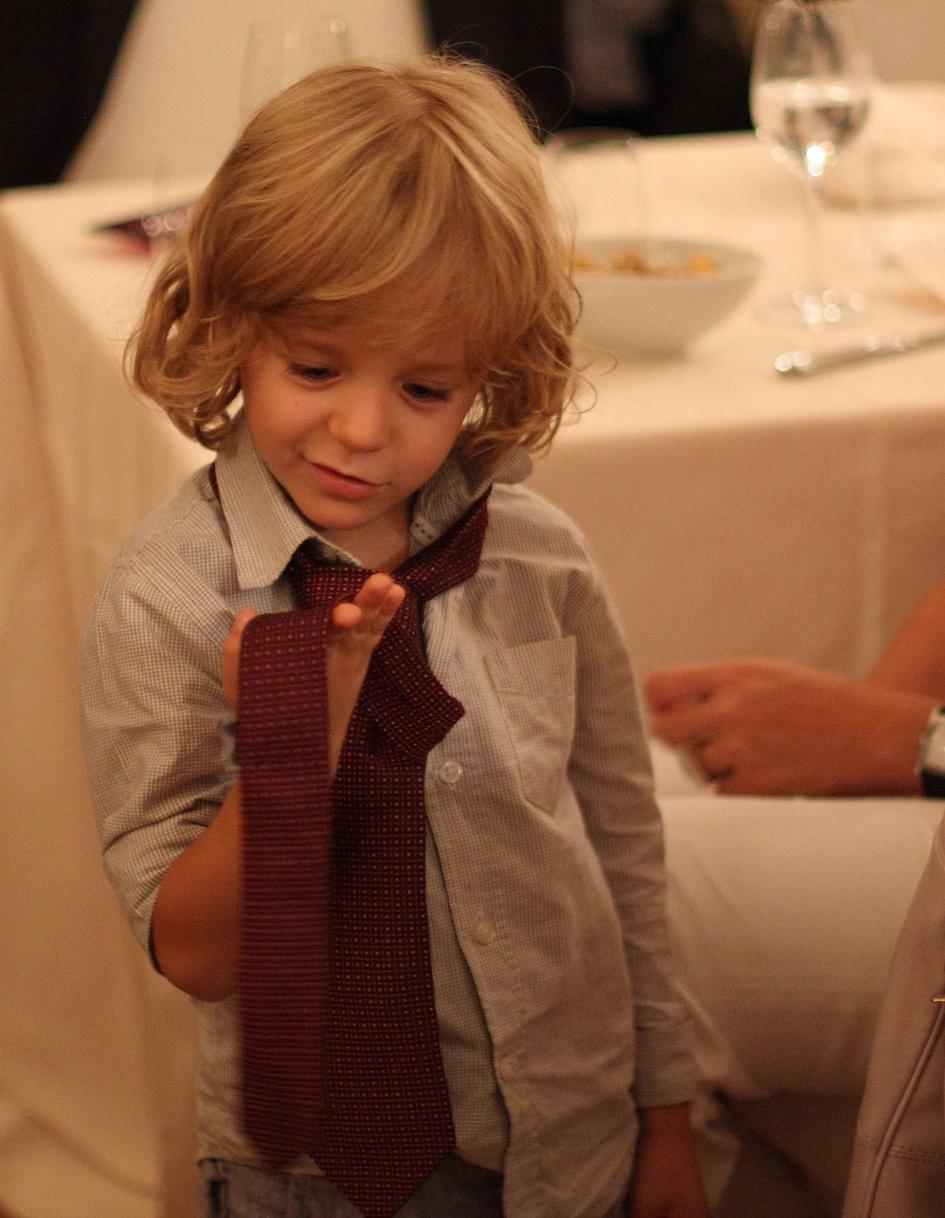Question: how many children are there?
Choices:
A. Two.
B. Three.
C. Four.
D. One.
Answer with the letter. Answer: D Question: what color is the tie?
Choices:
A. Blue.
B. Red.
C. Silver.
D. Burgundy.
Answer with the letter. Answer: D Question: what has a peach cloth?
Choices:
A. A dining table.
B. A chair.
C. A shelf.
D. A counter.
Answer with the letter. Answer: A Question: how is a small boy wearing a tie around his neck looking?
Choices:
A. Scared.
B. Happy.
C. Confused.
D. Puzzled.
Answer with the letter. Answer: D Question: who has wavy hair?
Choices:
A. The woman.
B. The child.
C. The boy.
D. The teacher.
Answer with the letter. Answer: C Question: what can be seen just behind the boy?
Choices:
A. An adult's hand and leg.
B. The teacher.
C. A woman.
D. A dad.
Answer with the letter. Answer: A Question: what is the boy wearing?
Choices:
A. A shirt.
B. No pants.
C. A blue tie.
D. A maroon tie with a pattern.
Answer with the letter. Answer: D Question: what is in the background?
Choices:
A. An umbrella.
B. A table with a white cloth.
C. Boats by the pier.
D. A city street.
Answer with the letter. Answer: B Question: who is wearing the oversized clothing next to the barely visible person?
Choices:
A. A bodyguard.
B. A tot.
C. An old man.
D. A woman.
Answer with the letter. Answer: B Question: who has curled hair?
Choices:
A. The boy.
B. The dog.
C. The girl.
D. The man.
Answer with the letter. Answer: A Question: what is on the table?
Choices:
A. A plate of food.
B. A paper napkin.
C. A bottle of ketchup.
D. A utensil, bowl and goblet.
Answer with the letter. Answer: D Question: who is caucasian?
Choices:
A. Boy.
B. Girl.
C. Lady.
D. Man.
Answer with the letter. Answer: A Question: what is red?
Choices:
A. Tie.
B. Shirt.
C. Tennis shoes.
D. Shorts.
Answer with the letter. Answer: A Question: who is in the picture?
Choices:
A. A baby.
B. Young girl.
C. Toddler boy.
D. A yong boy with a man's tie.
Answer with the letter. Answer: D Question: how is the boy dressed?
Choices:
A. Casual.
B. With a blue and white striped button up dress shirt and maroon tie.
C. Formal.
D. Swimwear.
Answer with the letter. Answer: B Question: who is this?
Choices:
A. A tiny baby.
B. A big girl.
C. A little boy.
D. A fragile woman.
Answer with the letter. Answer: C Question: where is he located?
Choices:
A. Dining room.
B. Living room.
C. Bedroom.
D. Bathroom.
Answer with the letter. Answer: A Question: what look does the child have on his face?
Choices:
A. A look of amazement.
B. Sadness.
C. Anger.
D. Humor.
Answer with the letter. Answer: A 